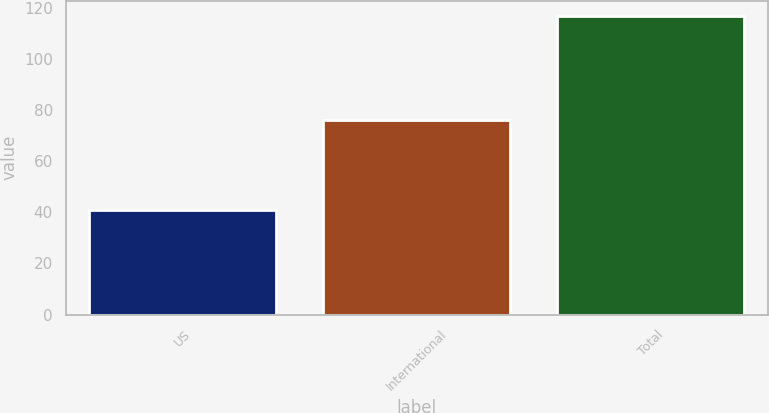<chart> <loc_0><loc_0><loc_500><loc_500><bar_chart><fcel>US<fcel>International<fcel>Total<nl><fcel>41<fcel>76<fcel>117<nl></chart> 